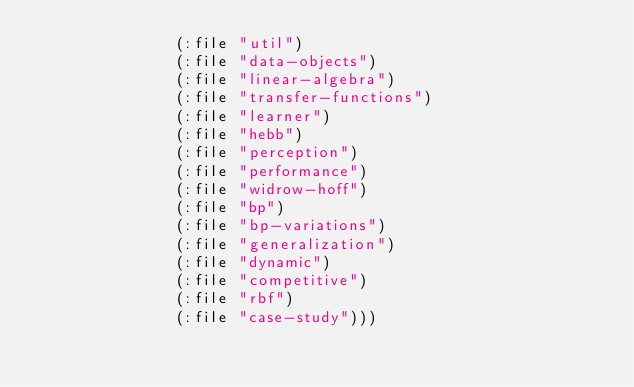Convert code to text. <code><loc_0><loc_0><loc_500><loc_500><_Lisp_>               (:file "util")
               (:file "data-objects")
               (:file "linear-algebra")
               (:file "transfer-functions")
               (:file "learner")
               (:file "hebb")
               (:file "perception")
               (:file "performance")
               (:file "widrow-hoff")
               (:file "bp")
               (:file "bp-variations")
               (:file "generalization")
               (:file "dynamic")
               (:file "competitive")
               (:file "rbf")
               (:file "case-study")))
</code> 